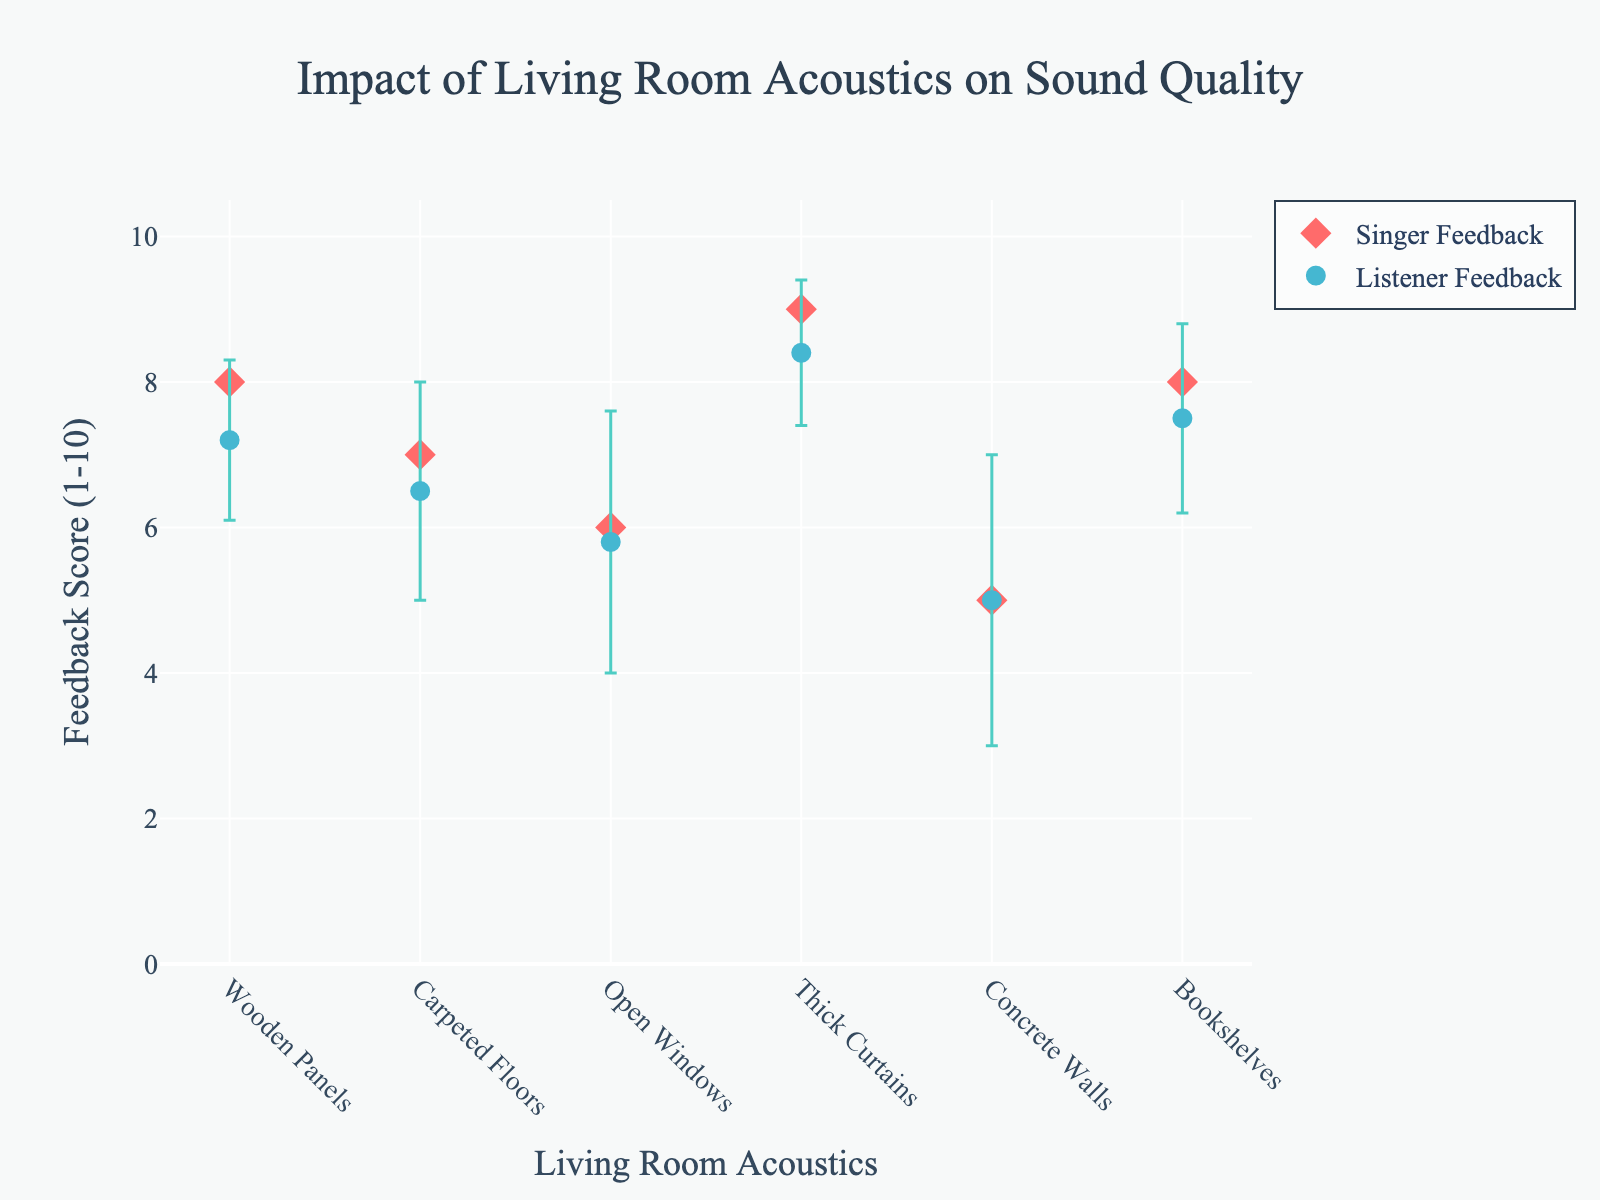What's the maximum feedback score given by the singer? The highest feedback score from the singer can be identified by looking at the markers representing the singer's feedback on the y-axis. The highest point is "Thick Curtains" with a score of 9.
Answer: 9 What is the most common type of living room acoustic treatment that both the singer and listeners preferred? To find the most common preferred acoustic treatment, compare the feedback scores from both the singer and listeners. "Thick Curtains" have the highest scores for both groups, with the singer scoring 9, and listeners averaging 8.4.
Answer: Thick Curtains Which living room acoustic has the highest variability in listener feedback? The highest variability in listener feedback can be determined by the longest error bar associated with each condition. "Concrete Walls" shows the highest error bar with a standard deviation of 2.0.
Answer: Concrete Walls Which two living room acoustics have the same singer feedback score? By comparing the markers for singer feedback on the y-axis, "Wooden Panels" and "Bookshelves" both have the same singer feedback score of 8.
Answer: Wooden Panels, Bookshelves How much higher is the singer's feedback for "Thick Curtains" compared to "Concrete Walls"? The singer's feedback for "Thick Curtains" is 9, while for "Concrete Walls" it is 5. The difference is 9 - 5 = 4.
Answer: 4 What is the average listener feedback score for "Wooden Panels" and "Bookshelves"? The listener feedback scores are 7.2 for "Wooden Panels" and 7.5 for "Bookshelves." The average is (7.2 + 7.5) / 2 = 7.35.
Answer: 7.35 Which acoustic treatment had the lowest average listener feedback score? The average listener feedback score is lowest for "Concrete Walls" at 5.0.
Answer: Concrete Walls What is the range of listener feedback scores for "Open Windows"? "Open Windows" has a mean listener feedback of 5.8 with a standard deviation of 1.8. The possible range (mean ± std dev) is 5.8 - 1.8 to 5.8 + 1.8, which is 4.0 to 7.6.
Answer: 4.0 to 7.6 How many types of living room acoustics are depicted in the figure? By counting the different categories on the x-axis, there are 6 types of living room acoustics shown: Wooden Panels, Carpeted Floors, Open Windows, Thick Curtains, Concrete Walls, and Bookshelves.
Answer: 6 For which living room acoustic is the listener feedback closest to the singer's feedback? By comparing the listener feedback with the singer feedback and looking for the smallest difference, "Thick Curtains" has the closest scores with singer feedback at 9 and listener feedback at 8.4. The difference is 0.6.
Answer: Thick Curtains 